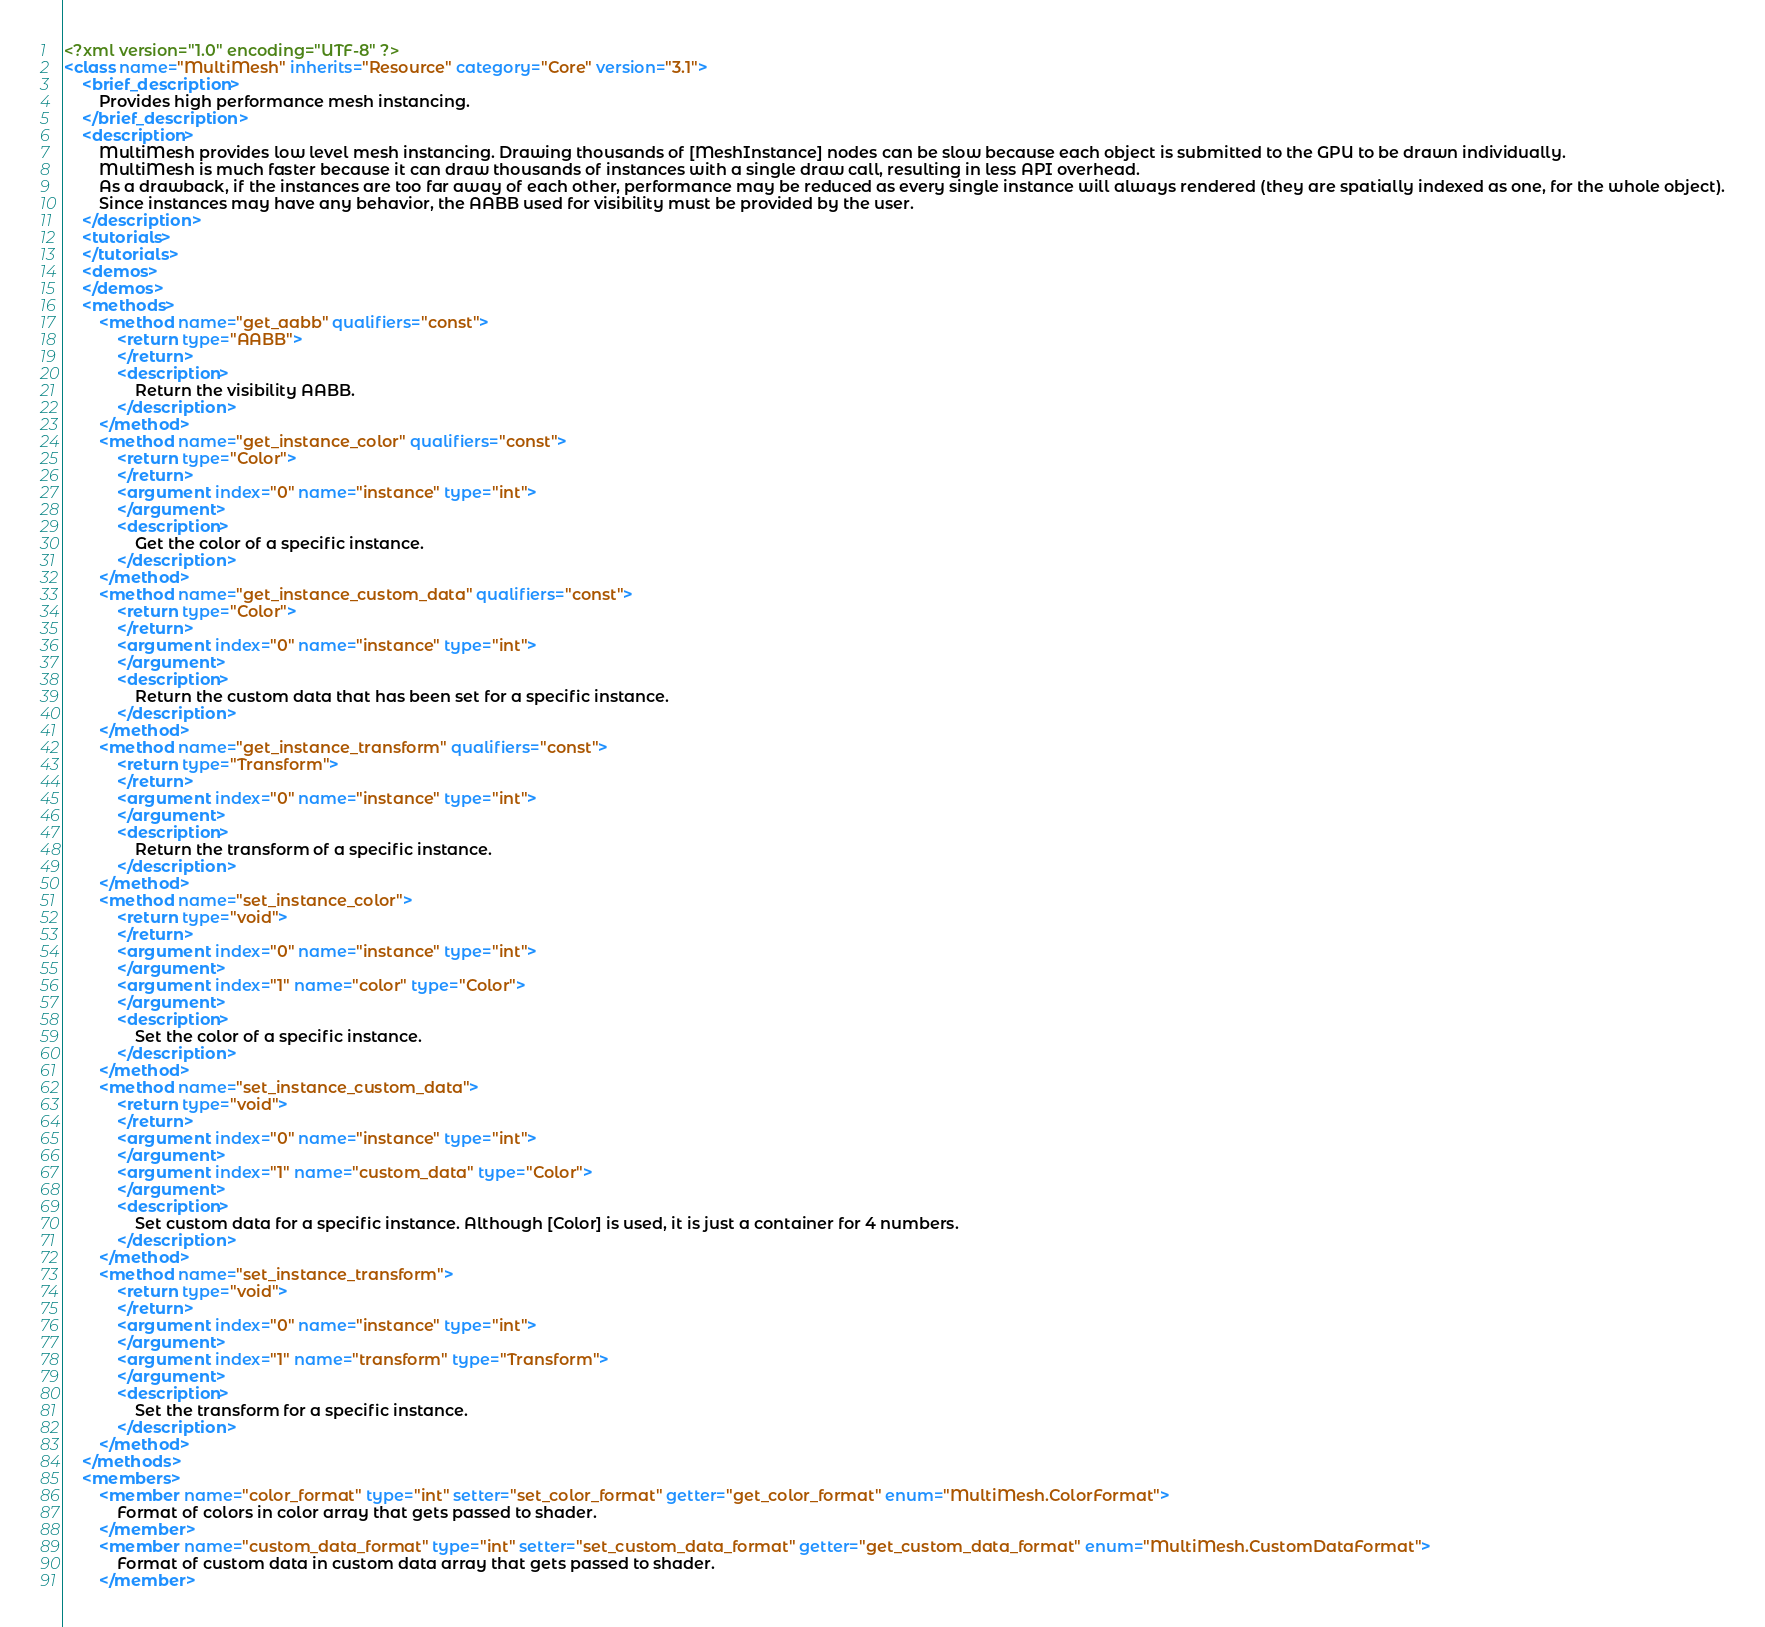<code> <loc_0><loc_0><loc_500><loc_500><_XML_><?xml version="1.0" encoding="UTF-8" ?>
<class name="MultiMesh" inherits="Resource" category="Core" version="3.1">
	<brief_description>
		Provides high performance mesh instancing.
	</brief_description>
	<description>
		MultiMesh provides low level mesh instancing. Drawing thousands of [MeshInstance] nodes can be slow because each object is submitted to the GPU to be drawn individually.
		MultiMesh is much faster because it can draw thousands of instances with a single draw call, resulting in less API overhead.
		As a drawback, if the instances are too far away of each other, performance may be reduced as every single instance will always rendered (they are spatially indexed as one, for the whole object).
		Since instances may have any behavior, the AABB used for visibility must be provided by the user.
	</description>
	<tutorials>
	</tutorials>
	<demos>
	</demos>
	<methods>
		<method name="get_aabb" qualifiers="const">
			<return type="AABB">
			</return>
			<description>
				Return the visibility AABB.
			</description>
		</method>
		<method name="get_instance_color" qualifiers="const">
			<return type="Color">
			</return>
			<argument index="0" name="instance" type="int">
			</argument>
			<description>
				Get the color of a specific instance.
			</description>
		</method>
		<method name="get_instance_custom_data" qualifiers="const">
			<return type="Color">
			</return>
			<argument index="0" name="instance" type="int">
			</argument>
			<description>
				Return the custom data that has been set for a specific instance.
			</description>
		</method>
		<method name="get_instance_transform" qualifiers="const">
			<return type="Transform">
			</return>
			<argument index="0" name="instance" type="int">
			</argument>
			<description>
				Return the transform of a specific instance.
			</description>
		</method>
		<method name="set_instance_color">
			<return type="void">
			</return>
			<argument index="0" name="instance" type="int">
			</argument>
			<argument index="1" name="color" type="Color">
			</argument>
			<description>
				Set the color of a specific instance.
			</description>
		</method>
		<method name="set_instance_custom_data">
			<return type="void">
			</return>
			<argument index="0" name="instance" type="int">
			</argument>
			<argument index="1" name="custom_data" type="Color">
			</argument>
			<description>
				Set custom data for a specific instance. Although [Color] is used, it is just a container for 4 numbers.
			</description>
		</method>
		<method name="set_instance_transform">
			<return type="void">
			</return>
			<argument index="0" name="instance" type="int">
			</argument>
			<argument index="1" name="transform" type="Transform">
			</argument>
			<description>
				Set the transform for a specific instance.
			</description>
		</method>
	</methods>
	<members>
		<member name="color_format" type="int" setter="set_color_format" getter="get_color_format" enum="MultiMesh.ColorFormat">
			Format of colors in color array that gets passed to shader.
		</member>
		<member name="custom_data_format" type="int" setter="set_custom_data_format" getter="get_custom_data_format" enum="MultiMesh.CustomDataFormat">
			Format of custom data in custom data array that gets passed to shader.
		</member></code> 